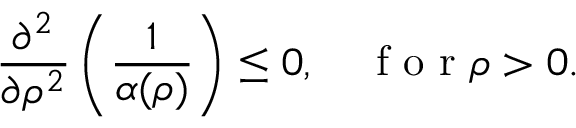<formula> <loc_0><loc_0><loc_500><loc_500>\frac { \partial ^ { 2 } } { \partial \rho ^ { 2 } } \left ( \frac { 1 } { \alpha ( \rho ) } \right ) \leq 0 , \quad f o r \rho > 0 .</formula> 